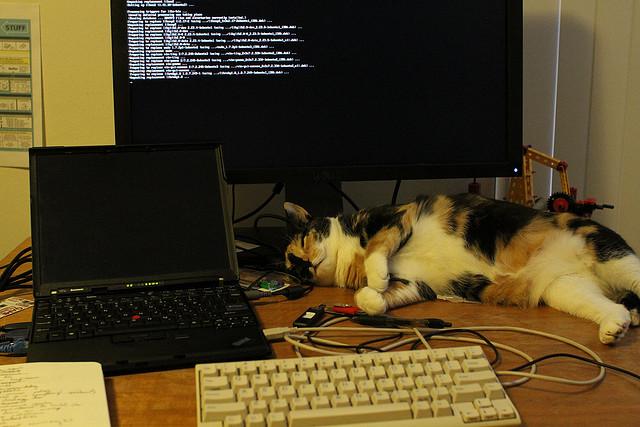Is the cat sleeping?
Concise answer only. Yes. Is this cat playing a game on the computer?
Keep it brief. No. How many keyboards are there?
Quick response, please. 2. 